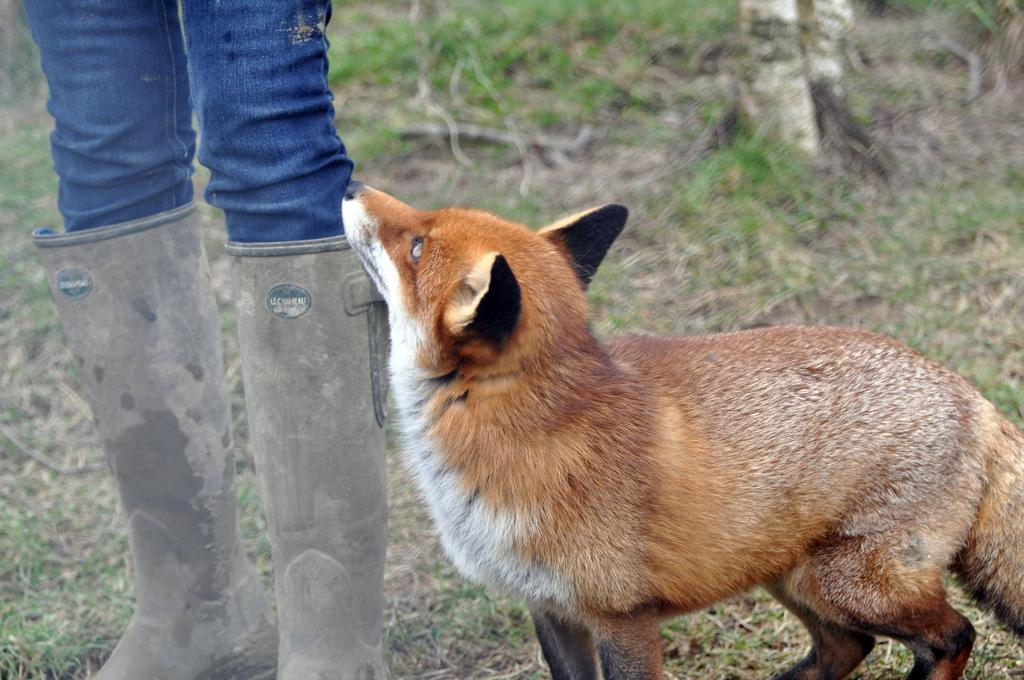What is the main subject of the image? There is a person standing in the image. What is the person wearing on their feet? The person is wearing shoes. Is there any other living creature in the image besides the person? Yes, there is a dog is standing beside the person. What type of surface is visible in the image? There is grass on the floor in the image. What type of rabbits can be seen having lunch in the image? There are no rabbits or lunch depicted in the image; it features a person standing with a dog on grass. 